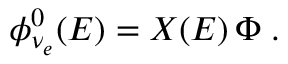<formula> <loc_0><loc_0><loc_500><loc_500>\phi _ { \nu _ { e } } ^ { 0 } ( E ) = X ( E ) \, \Phi \, .</formula> 